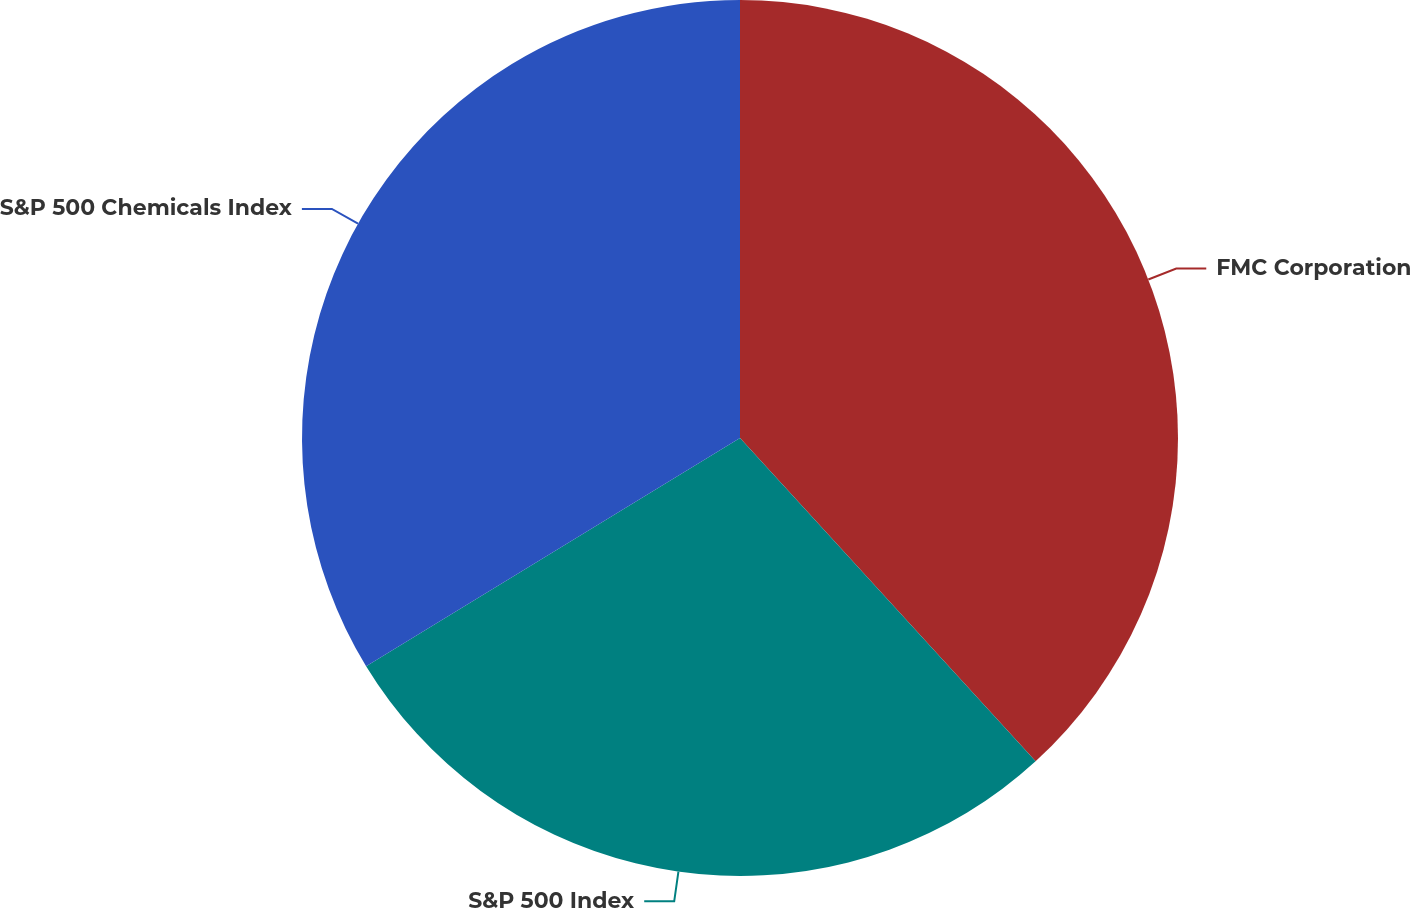<chart> <loc_0><loc_0><loc_500><loc_500><pie_chart><fcel>FMC Corporation<fcel>S&P 500 Index<fcel>S&P 500 Chemicals Index<nl><fcel>38.21%<fcel>28.07%<fcel>33.72%<nl></chart> 